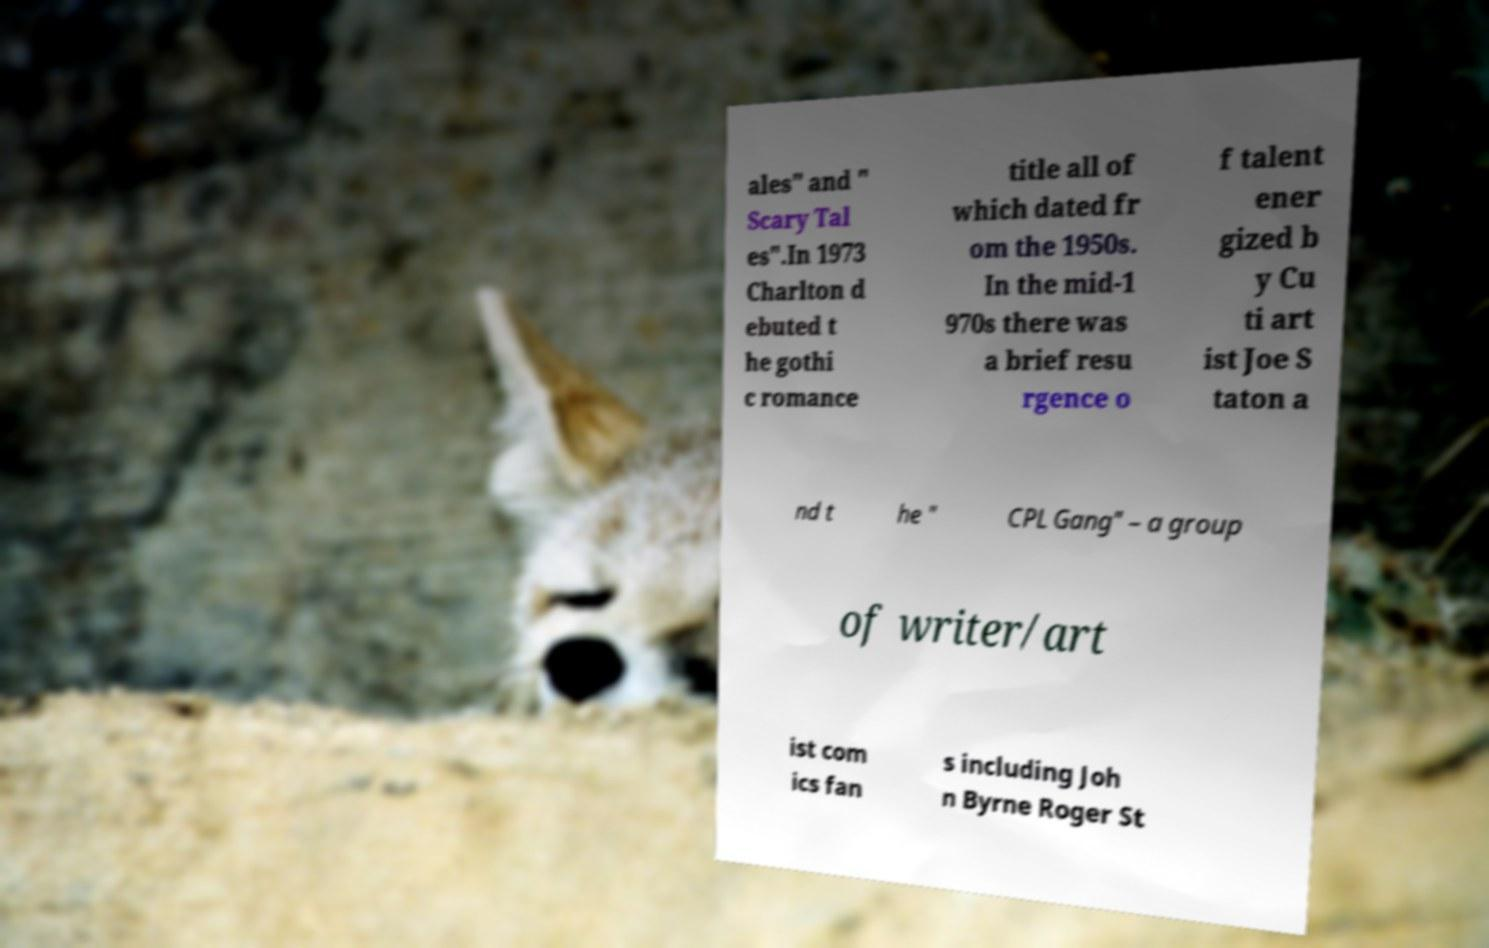Please read and relay the text visible in this image. What does it say? ales" and " Scary Tal es".In 1973 Charlton d ebuted t he gothi c romance title all of which dated fr om the 1950s. In the mid-1 970s there was a brief resu rgence o f talent ener gized b y Cu ti art ist Joe S taton a nd t he " CPL Gang" – a group of writer/art ist com ics fan s including Joh n Byrne Roger St 